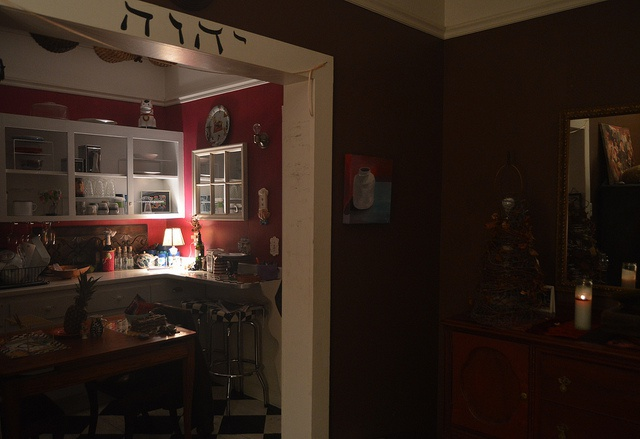Describe the objects in this image and their specific colors. I can see dining table in gray, black, maroon, and brown tones, chair in gray and black tones, chair in gray, black, maroon, and brown tones, vase in black and gray tones, and chair in black and gray tones in this image. 